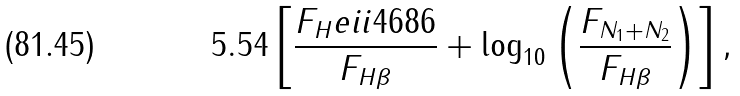<formula> <loc_0><loc_0><loc_500><loc_500>5 . 5 4 \left [ \frac { F _ { H } e i i 4 6 8 6 } { F _ { H \beta } } + \log _ { 1 0 } \left ( \frac { F _ { N _ { 1 } + N _ { 2 } } } { F _ { H \beta } } \right ) \right ] ,</formula> 